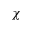Convert formula to latex. <formula><loc_0><loc_0><loc_500><loc_500>\chi</formula> 